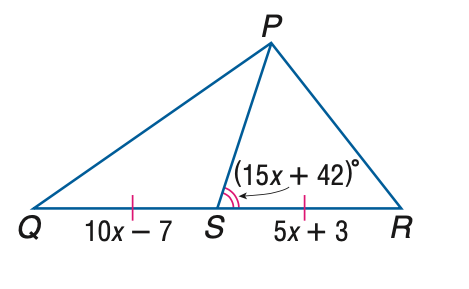Question: Find x if P S is a median of \triangle P Q R.
Choices:
A. 1
B. 2
C. 3
D. 4
Answer with the letter. Answer: B 